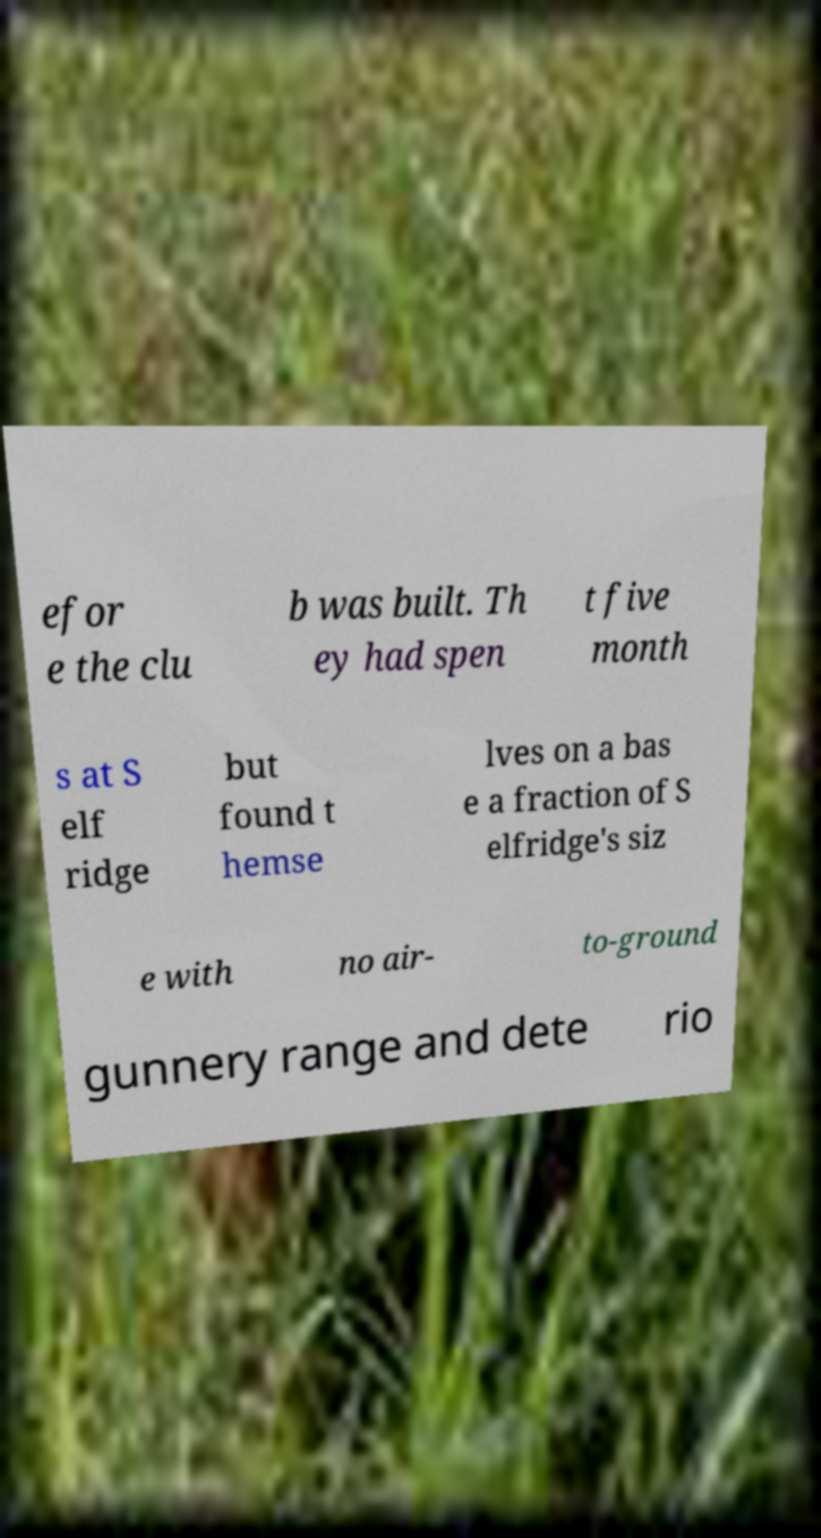Can you read and provide the text displayed in the image?This photo seems to have some interesting text. Can you extract and type it out for me? efor e the clu b was built. Th ey had spen t five month s at S elf ridge but found t hemse lves on a bas e a fraction of S elfridge's siz e with no air- to-ground gunnery range and dete rio 